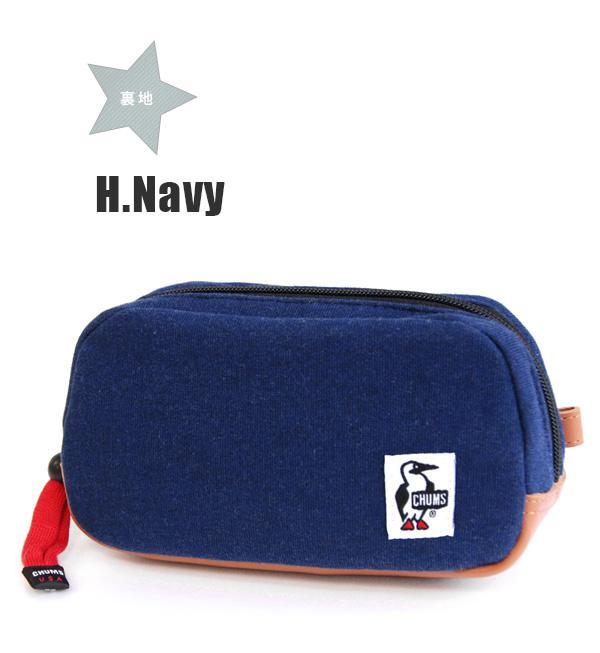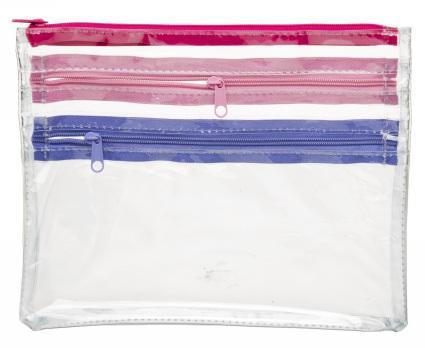The first image is the image on the left, the second image is the image on the right. For the images displayed, is the sentence "There is a thick pencil case and a thin one, both closed." factually correct? Answer yes or no. Yes. The first image is the image on the left, the second image is the image on the right. Analyze the images presented: Is the assertion "An image shows a closed, flat case with red and blue elements and multiple zippers across the front." valid? Answer yes or no. Yes. 